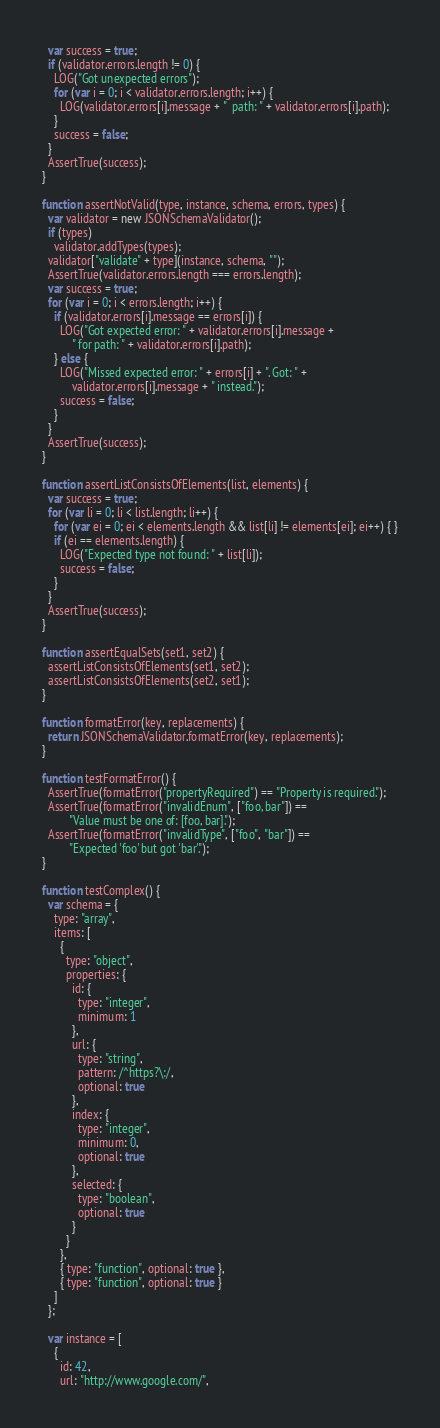<code> <loc_0><loc_0><loc_500><loc_500><_JavaScript_>  var success = true;
  if (validator.errors.length != 0) {
    LOG("Got unexpected errors");
    for (var i = 0; i < validator.errors.length; i++) {
      LOG(validator.errors[i].message + "  path: " + validator.errors[i].path);
    }
    success = false;
  }
  AssertTrue(success);
}

function assertNotValid(type, instance, schema, errors, types) {
  var validator = new JSONSchemaValidator();
  if (types)
    validator.addTypes(types);
  validator["validate" + type](instance, schema, "");
  AssertTrue(validator.errors.length === errors.length);
  var success = true;
  for (var i = 0; i < errors.length; i++) {
    if (validator.errors[i].message == errors[i]) {
      LOG("Got expected error: " + validator.errors[i].message +
          " for path: " + validator.errors[i].path);
    } else {
      LOG("Missed expected error: " + errors[i] + ". Got: " +
          validator.errors[i].message + " instead.");
      success = false;
    }
  }
  AssertTrue(success);
}

function assertListConsistsOfElements(list, elements) {
  var success = true;
  for (var li = 0; li < list.length; li++) {
    for (var ei = 0; ei < elements.length && list[li] != elements[ei]; ei++) { }
    if (ei == elements.length) {
      LOG("Expected type not found: " + list[li]);
      success = false;
    }
  }
  AssertTrue(success);
}

function assertEqualSets(set1, set2) {
  assertListConsistsOfElements(set1, set2);
  assertListConsistsOfElements(set2, set1);
}

function formatError(key, replacements) {
  return JSONSchemaValidator.formatError(key, replacements);
}

function testFormatError() {
  AssertTrue(formatError("propertyRequired") == "Property is required.");
  AssertTrue(formatError("invalidEnum", ["foo, bar"]) ==
         "Value must be one of: [foo, bar].");
  AssertTrue(formatError("invalidType", ["foo", "bar"]) ==
         "Expected 'foo' but got 'bar'.");
}

function testComplex() {
  var schema = {
    type: "array",
    items: [
      {
        type: "object",
        properties: {
          id: {
            type: "integer",
            minimum: 1
          },
          url: {
            type: "string",
            pattern: /^https?\:/,
            optional: true
          },
          index: {
            type: "integer",
            minimum: 0,
            optional: true
          },
          selected: {
            type: "boolean",
            optional: true
          }
        }
      },
      { type: "function", optional: true },
      { type: "function", optional: true }
    ]
  };

  var instance = [
    {
      id: 42,
      url: "http://www.google.com/",</code> 